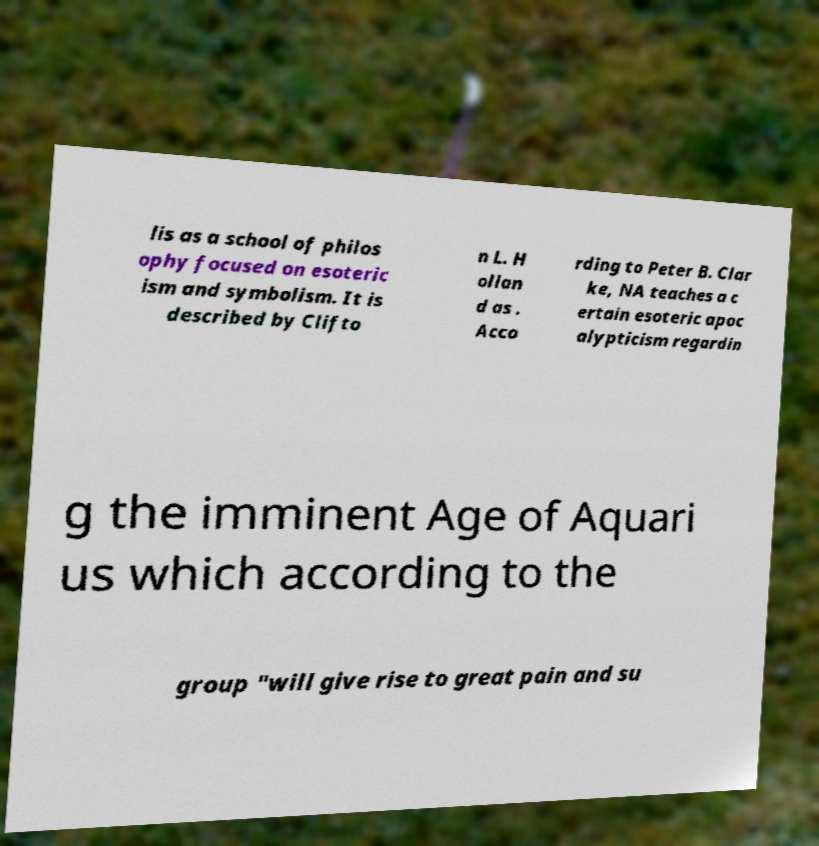Could you assist in decoding the text presented in this image and type it out clearly? lis as a school of philos ophy focused on esoteric ism and symbolism. It is described by Clifto n L. H ollan d as . Acco rding to Peter B. Clar ke, NA teaches a c ertain esoteric apoc alypticism regardin g the imminent Age of Aquari us which according to the group "will give rise to great pain and su 